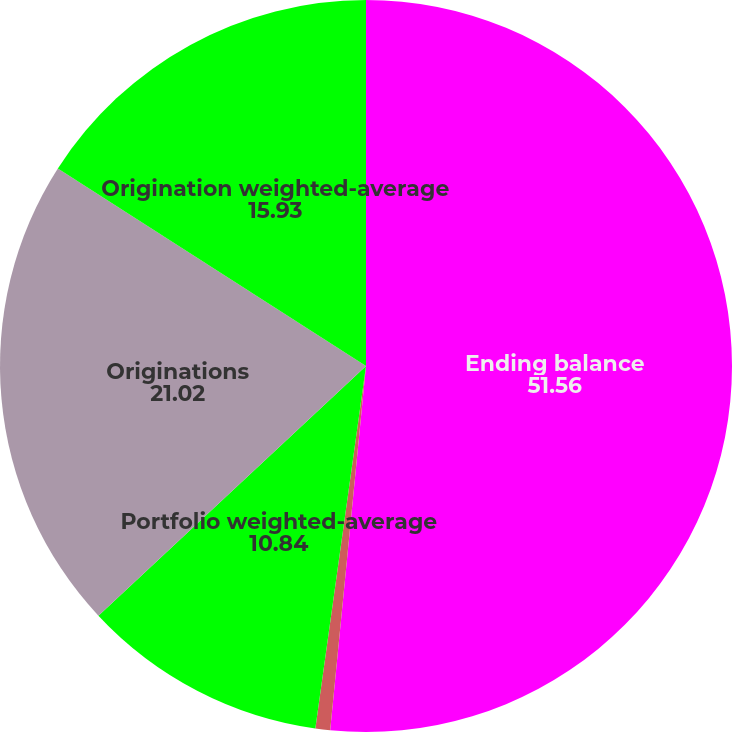Convert chart to OTSL. <chart><loc_0><loc_0><loc_500><loc_500><pie_chart><fcel>Ending balance<fcel>Portfolio weighted-average LTV<fcel>Portfolio weighted-average<fcel>Originations<fcel>Origination weighted-average<nl><fcel>51.56%<fcel>0.65%<fcel>10.84%<fcel>21.02%<fcel>15.93%<nl></chart> 